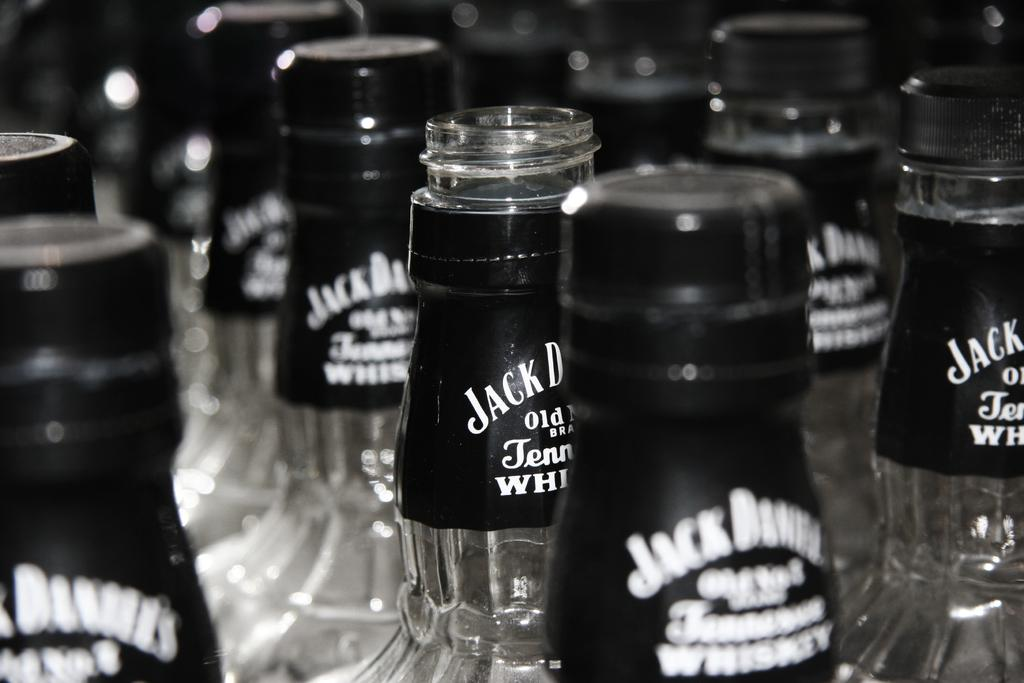What type of containers are present in the image? There are bottles made of glass in the image. Are there any distinguishing features on the bottles? Some of the bottles have stickers on them. What is the status of the cans in the image? Some of the cans are opened, and some are closed. How much does the cow weigh in the image? There is no cow present in the image, so its weight cannot be determined. 